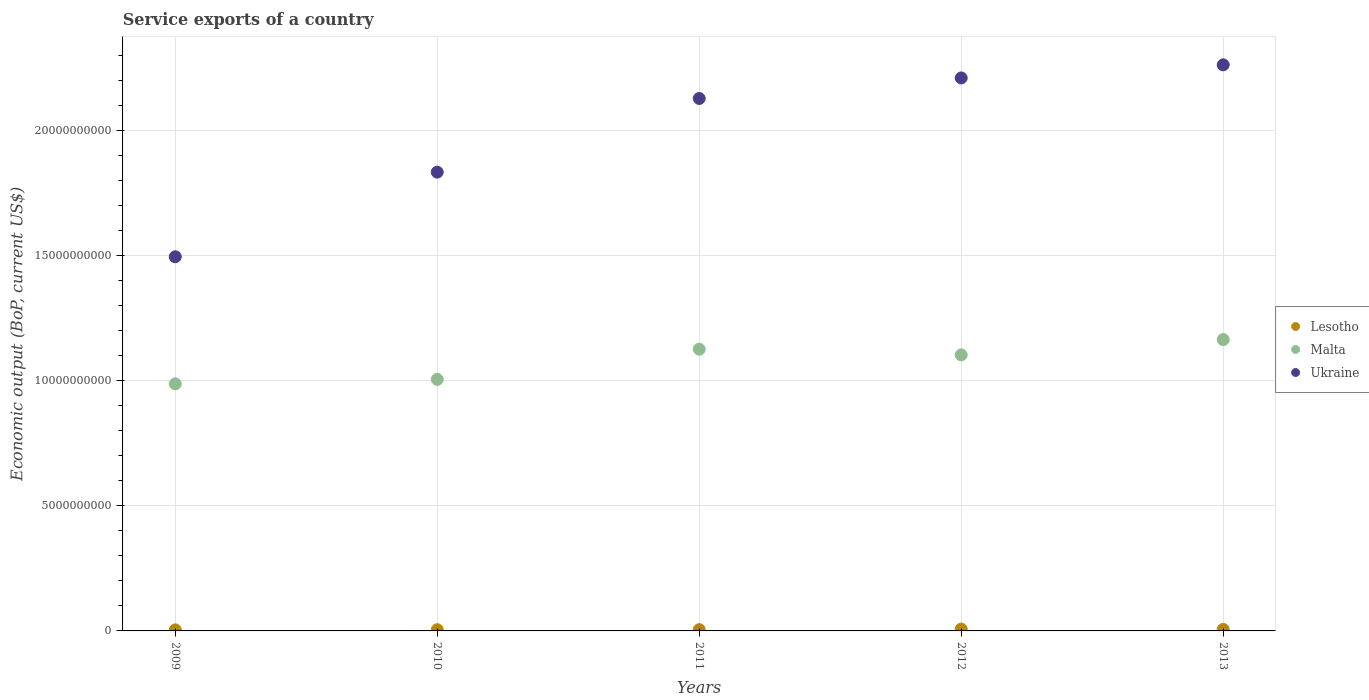How many different coloured dotlines are there?
Provide a short and direct response. 3. Is the number of dotlines equal to the number of legend labels?
Keep it short and to the point. Yes. What is the service exports in Ukraine in 2011?
Provide a short and direct response. 2.13e+1. Across all years, what is the maximum service exports in Malta?
Make the answer very short. 1.16e+1. Across all years, what is the minimum service exports in Malta?
Provide a short and direct response. 9.87e+09. What is the total service exports in Ukraine in the graph?
Your answer should be compact. 9.92e+1. What is the difference between the service exports in Lesotho in 2011 and that in 2012?
Offer a terse response. -2.21e+07. What is the difference between the service exports in Malta in 2013 and the service exports in Ukraine in 2012?
Ensure brevity in your answer.  -1.05e+1. What is the average service exports in Lesotho per year?
Provide a succinct answer. 5.47e+07. In the year 2009, what is the difference between the service exports in Ukraine and service exports in Malta?
Keep it short and to the point. 5.08e+09. In how many years, is the service exports in Lesotho greater than 3000000000 US$?
Keep it short and to the point. 0. What is the ratio of the service exports in Malta in 2009 to that in 2012?
Give a very brief answer. 0.89. What is the difference between the highest and the second highest service exports in Ukraine?
Offer a very short reply. 5.24e+08. What is the difference between the highest and the lowest service exports in Ukraine?
Make the answer very short. 7.67e+09. Does the service exports in Malta monotonically increase over the years?
Provide a short and direct response. No. Is the service exports in Malta strictly greater than the service exports in Lesotho over the years?
Provide a short and direct response. Yes. Is the service exports in Ukraine strictly less than the service exports in Malta over the years?
Your answer should be compact. No. What is the difference between two consecutive major ticks on the Y-axis?
Ensure brevity in your answer.  5.00e+09. Does the graph contain grids?
Your answer should be very brief. Yes. How many legend labels are there?
Your response must be concise. 3. How are the legend labels stacked?
Keep it short and to the point. Vertical. What is the title of the graph?
Give a very brief answer. Service exports of a country. Does "Central African Republic" appear as one of the legend labels in the graph?
Make the answer very short. No. What is the label or title of the X-axis?
Provide a short and direct response. Years. What is the label or title of the Y-axis?
Offer a very short reply. Economic output (BoP, current US$). What is the Economic output (BoP, current US$) in Lesotho in 2009?
Your answer should be compact. 4.15e+07. What is the Economic output (BoP, current US$) in Malta in 2009?
Ensure brevity in your answer.  9.87e+09. What is the Economic output (BoP, current US$) in Ukraine in 2009?
Offer a very short reply. 1.49e+1. What is the Economic output (BoP, current US$) of Lesotho in 2010?
Provide a succinct answer. 4.77e+07. What is the Economic output (BoP, current US$) in Malta in 2010?
Give a very brief answer. 1.00e+1. What is the Economic output (BoP, current US$) of Ukraine in 2010?
Your answer should be compact. 1.83e+1. What is the Economic output (BoP, current US$) of Lesotho in 2011?
Your answer should be compact. 5.08e+07. What is the Economic output (BoP, current US$) of Malta in 2011?
Keep it short and to the point. 1.13e+1. What is the Economic output (BoP, current US$) of Ukraine in 2011?
Offer a very short reply. 2.13e+1. What is the Economic output (BoP, current US$) of Lesotho in 2012?
Offer a terse response. 7.29e+07. What is the Economic output (BoP, current US$) of Malta in 2012?
Your answer should be compact. 1.10e+1. What is the Economic output (BoP, current US$) of Ukraine in 2012?
Ensure brevity in your answer.  2.21e+1. What is the Economic output (BoP, current US$) in Lesotho in 2013?
Ensure brevity in your answer.  6.03e+07. What is the Economic output (BoP, current US$) of Malta in 2013?
Your answer should be very brief. 1.16e+1. What is the Economic output (BoP, current US$) in Ukraine in 2013?
Your answer should be very brief. 2.26e+1. Across all years, what is the maximum Economic output (BoP, current US$) of Lesotho?
Keep it short and to the point. 7.29e+07. Across all years, what is the maximum Economic output (BoP, current US$) of Malta?
Keep it short and to the point. 1.16e+1. Across all years, what is the maximum Economic output (BoP, current US$) in Ukraine?
Make the answer very short. 2.26e+1. Across all years, what is the minimum Economic output (BoP, current US$) in Lesotho?
Offer a terse response. 4.15e+07. Across all years, what is the minimum Economic output (BoP, current US$) in Malta?
Your response must be concise. 9.87e+09. Across all years, what is the minimum Economic output (BoP, current US$) in Ukraine?
Make the answer very short. 1.49e+1. What is the total Economic output (BoP, current US$) of Lesotho in the graph?
Ensure brevity in your answer.  2.73e+08. What is the total Economic output (BoP, current US$) of Malta in the graph?
Your response must be concise. 5.38e+1. What is the total Economic output (BoP, current US$) of Ukraine in the graph?
Provide a short and direct response. 9.92e+1. What is the difference between the Economic output (BoP, current US$) in Lesotho in 2009 and that in 2010?
Offer a terse response. -6.19e+06. What is the difference between the Economic output (BoP, current US$) of Malta in 2009 and that in 2010?
Provide a succinct answer. -1.80e+08. What is the difference between the Economic output (BoP, current US$) of Ukraine in 2009 and that in 2010?
Offer a very short reply. -3.38e+09. What is the difference between the Economic output (BoP, current US$) of Lesotho in 2009 and that in 2011?
Your answer should be very brief. -9.29e+06. What is the difference between the Economic output (BoP, current US$) of Malta in 2009 and that in 2011?
Give a very brief answer. -1.39e+09. What is the difference between the Economic output (BoP, current US$) of Ukraine in 2009 and that in 2011?
Provide a succinct answer. -6.32e+09. What is the difference between the Economic output (BoP, current US$) of Lesotho in 2009 and that in 2012?
Your response must be concise. -3.14e+07. What is the difference between the Economic output (BoP, current US$) of Malta in 2009 and that in 2012?
Your answer should be compact. -1.16e+09. What is the difference between the Economic output (BoP, current US$) of Ukraine in 2009 and that in 2012?
Offer a terse response. -7.14e+09. What is the difference between the Economic output (BoP, current US$) of Lesotho in 2009 and that in 2013?
Keep it short and to the point. -1.88e+07. What is the difference between the Economic output (BoP, current US$) of Malta in 2009 and that in 2013?
Provide a short and direct response. -1.77e+09. What is the difference between the Economic output (BoP, current US$) in Ukraine in 2009 and that in 2013?
Offer a very short reply. -7.67e+09. What is the difference between the Economic output (BoP, current US$) in Lesotho in 2010 and that in 2011?
Ensure brevity in your answer.  -3.10e+06. What is the difference between the Economic output (BoP, current US$) of Malta in 2010 and that in 2011?
Provide a succinct answer. -1.21e+09. What is the difference between the Economic output (BoP, current US$) of Ukraine in 2010 and that in 2011?
Your answer should be compact. -2.94e+09. What is the difference between the Economic output (BoP, current US$) in Lesotho in 2010 and that in 2012?
Offer a very short reply. -2.52e+07. What is the difference between the Economic output (BoP, current US$) of Malta in 2010 and that in 2012?
Provide a succinct answer. -9.79e+08. What is the difference between the Economic output (BoP, current US$) of Ukraine in 2010 and that in 2012?
Ensure brevity in your answer.  -3.76e+09. What is the difference between the Economic output (BoP, current US$) of Lesotho in 2010 and that in 2013?
Keep it short and to the point. -1.26e+07. What is the difference between the Economic output (BoP, current US$) of Malta in 2010 and that in 2013?
Keep it short and to the point. -1.59e+09. What is the difference between the Economic output (BoP, current US$) of Ukraine in 2010 and that in 2013?
Ensure brevity in your answer.  -4.29e+09. What is the difference between the Economic output (BoP, current US$) of Lesotho in 2011 and that in 2012?
Your answer should be compact. -2.21e+07. What is the difference between the Economic output (BoP, current US$) in Malta in 2011 and that in 2012?
Your answer should be compact. 2.27e+08. What is the difference between the Economic output (BoP, current US$) in Ukraine in 2011 and that in 2012?
Give a very brief answer. -8.20e+08. What is the difference between the Economic output (BoP, current US$) of Lesotho in 2011 and that in 2013?
Offer a very short reply. -9.50e+06. What is the difference between the Economic output (BoP, current US$) in Malta in 2011 and that in 2013?
Offer a terse response. -3.83e+08. What is the difference between the Economic output (BoP, current US$) of Ukraine in 2011 and that in 2013?
Ensure brevity in your answer.  -1.34e+09. What is the difference between the Economic output (BoP, current US$) in Lesotho in 2012 and that in 2013?
Make the answer very short. 1.26e+07. What is the difference between the Economic output (BoP, current US$) in Malta in 2012 and that in 2013?
Keep it short and to the point. -6.10e+08. What is the difference between the Economic output (BoP, current US$) of Ukraine in 2012 and that in 2013?
Give a very brief answer. -5.24e+08. What is the difference between the Economic output (BoP, current US$) of Lesotho in 2009 and the Economic output (BoP, current US$) of Malta in 2010?
Give a very brief answer. -1.00e+1. What is the difference between the Economic output (BoP, current US$) of Lesotho in 2009 and the Economic output (BoP, current US$) of Ukraine in 2010?
Ensure brevity in your answer.  -1.83e+1. What is the difference between the Economic output (BoP, current US$) in Malta in 2009 and the Economic output (BoP, current US$) in Ukraine in 2010?
Provide a succinct answer. -8.46e+09. What is the difference between the Economic output (BoP, current US$) of Lesotho in 2009 and the Economic output (BoP, current US$) of Malta in 2011?
Your response must be concise. -1.12e+1. What is the difference between the Economic output (BoP, current US$) in Lesotho in 2009 and the Economic output (BoP, current US$) in Ukraine in 2011?
Provide a succinct answer. -2.12e+1. What is the difference between the Economic output (BoP, current US$) in Malta in 2009 and the Economic output (BoP, current US$) in Ukraine in 2011?
Provide a succinct answer. -1.14e+1. What is the difference between the Economic output (BoP, current US$) in Lesotho in 2009 and the Economic output (BoP, current US$) in Malta in 2012?
Your answer should be very brief. -1.10e+1. What is the difference between the Economic output (BoP, current US$) of Lesotho in 2009 and the Economic output (BoP, current US$) of Ukraine in 2012?
Offer a very short reply. -2.20e+1. What is the difference between the Economic output (BoP, current US$) of Malta in 2009 and the Economic output (BoP, current US$) of Ukraine in 2012?
Ensure brevity in your answer.  -1.22e+1. What is the difference between the Economic output (BoP, current US$) in Lesotho in 2009 and the Economic output (BoP, current US$) in Malta in 2013?
Provide a succinct answer. -1.16e+1. What is the difference between the Economic output (BoP, current US$) of Lesotho in 2009 and the Economic output (BoP, current US$) of Ukraine in 2013?
Give a very brief answer. -2.26e+1. What is the difference between the Economic output (BoP, current US$) of Malta in 2009 and the Economic output (BoP, current US$) of Ukraine in 2013?
Your answer should be very brief. -1.27e+1. What is the difference between the Economic output (BoP, current US$) in Lesotho in 2010 and the Economic output (BoP, current US$) in Malta in 2011?
Give a very brief answer. -1.12e+1. What is the difference between the Economic output (BoP, current US$) in Lesotho in 2010 and the Economic output (BoP, current US$) in Ukraine in 2011?
Keep it short and to the point. -2.12e+1. What is the difference between the Economic output (BoP, current US$) in Malta in 2010 and the Economic output (BoP, current US$) in Ukraine in 2011?
Provide a short and direct response. -1.12e+1. What is the difference between the Economic output (BoP, current US$) of Lesotho in 2010 and the Economic output (BoP, current US$) of Malta in 2012?
Provide a short and direct response. -1.10e+1. What is the difference between the Economic output (BoP, current US$) of Lesotho in 2010 and the Economic output (BoP, current US$) of Ukraine in 2012?
Provide a succinct answer. -2.20e+1. What is the difference between the Economic output (BoP, current US$) of Malta in 2010 and the Economic output (BoP, current US$) of Ukraine in 2012?
Offer a very short reply. -1.20e+1. What is the difference between the Economic output (BoP, current US$) of Lesotho in 2010 and the Economic output (BoP, current US$) of Malta in 2013?
Make the answer very short. -1.16e+1. What is the difference between the Economic output (BoP, current US$) of Lesotho in 2010 and the Economic output (BoP, current US$) of Ukraine in 2013?
Make the answer very short. -2.26e+1. What is the difference between the Economic output (BoP, current US$) in Malta in 2010 and the Economic output (BoP, current US$) in Ukraine in 2013?
Your answer should be compact. -1.26e+1. What is the difference between the Economic output (BoP, current US$) in Lesotho in 2011 and the Economic output (BoP, current US$) in Malta in 2012?
Ensure brevity in your answer.  -1.10e+1. What is the difference between the Economic output (BoP, current US$) of Lesotho in 2011 and the Economic output (BoP, current US$) of Ukraine in 2012?
Your answer should be very brief. -2.20e+1. What is the difference between the Economic output (BoP, current US$) in Malta in 2011 and the Economic output (BoP, current US$) in Ukraine in 2012?
Give a very brief answer. -1.08e+1. What is the difference between the Economic output (BoP, current US$) in Lesotho in 2011 and the Economic output (BoP, current US$) in Malta in 2013?
Ensure brevity in your answer.  -1.16e+1. What is the difference between the Economic output (BoP, current US$) in Lesotho in 2011 and the Economic output (BoP, current US$) in Ukraine in 2013?
Give a very brief answer. -2.26e+1. What is the difference between the Economic output (BoP, current US$) in Malta in 2011 and the Economic output (BoP, current US$) in Ukraine in 2013?
Offer a terse response. -1.14e+1. What is the difference between the Economic output (BoP, current US$) of Lesotho in 2012 and the Economic output (BoP, current US$) of Malta in 2013?
Your answer should be very brief. -1.16e+1. What is the difference between the Economic output (BoP, current US$) in Lesotho in 2012 and the Economic output (BoP, current US$) in Ukraine in 2013?
Provide a short and direct response. -2.25e+1. What is the difference between the Economic output (BoP, current US$) in Malta in 2012 and the Economic output (BoP, current US$) in Ukraine in 2013?
Keep it short and to the point. -1.16e+1. What is the average Economic output (BoP, current US$) in Lesotho per year?
Provide a short and direct response. 5.47e+07. What is the average Economic output (BoP, current US$) in Malta per year?
Provide a short and direct response. 1.08e+1. What is the average Economic output (BoP, current US$) in Ukraine per year?
Your answer should be very brief. 1.98e+1. In the year 2009, what is the difference between the Economic output (BoP, current US$) in Lesotho and Economic output (BoP, current US$) in Malta?
Your response must be concise. -9.83e+09. In the year 2009, what is the difference between the Economic output (BoP, current US$) of Lesotho and Economic output (BoP, current US$) of Ukraine?
Provide a short and direct response. -1.49e+1. In the year 2009, what is the difference between the Economic output (BoP, current US$) of Malta and Economic output (BoP, current US$) of Ukraine?
Provide a short and direct response. -5.08e+09. In the year 2010, what is the difference between the Economic output (BoP, current US$) in Lesotho and Economic output (BoP, current US$) in Malta?
Keep it short and to the point. -1.00e+1. In the year 2010, what is the difference between the Economic output (BoP, current US$) of Lesotho and Economic output (BoP, current US$) of Ukraine?
Provide a succinct answer. -1.83e+1. In the year 2010, what is the difference between the Economic output (BoP, current US$) in Malta and Economic output (BoP, current US$) in Ukraine?
Your response must be concise. -8.28e+09. In the year 2011, what is the difference between the Economic output (BoP, current US$) of Lesotho and Economic output (BoP, current US$) of Malta?
Make the answer very short. -1.12e+1. In the year 2011, what is the difference between the Economic output (BoP, current US$) in Lesotho and Economic output (BoP, current US$) in Ukraine?
Provide a succinct answer. -2.12e+1. In the year 2011, what is the difference between the Economic output (BoP, current US$) in Malta and Economic output (BoP, current US$) in Ukraine?
Offer a terse response. -1.00e+1. In the year 2012, what is the difference between the Economic output (BoP, current US$) of Lesotho and Economic output (BoP, current US$) of Malta?
Offer a very short reply. -1.10e+1. In the year 2012, what is the difference between the Economic output (BoP, current US$) of Lesotho and Economic output (BoP, current US$) of Ukraine?
Ensure brevity in your answer.  -2.20e+1. In the year 2012, what is the difference between the Economic output (BoP, current US$) of Malta and Economic output (BoP, current US$) of Ukraine?
Offer a terse response. -1.11e+1. In the year 2013, what is the difference between the Economic output (BoP, current US$) of Lesotho and Economic output (BoP, current US$) of Malta?
Offer a terse response. -1.16e+1. In the year 2013, what is the difference between the Economic output (BoP, current US$) of Lesotho and Economic output (BoP, current US$) of Ukraine?
Offer a very short reply. -2.26e+1. In the year 2013, what is the difference between the Economic output (BoP, current US$) in Malta and Economic output (BoP, current US$) in Ukraine?
Keep it short and to the point. -1.10e+1. What is the ratio of the Economic output (BoP, current US$) of Lesotho in 2009 to that in 2010?
Make the answer very short. 0.87. What is the ratio of the Economic output (BoP, current US$) in Malta in 2009 to that in 2010?
Your answer should be compact. 0.98. What is the ratio of the Economic output (BoP, current US$) in Ukraine in 2009 to that in 2010?
Offer a terse response. 0.82. What is the ratio of the Economic output (BoP, current US$) of Lesotho in 2009 to that in 2011?
Offer a very short reply. 0.82. What is the ratio of the Economic output (BoP, current US$) in Malta in 2009 to that in 2011?
Provide a succinct answer. 0.88. What is the ratio of the Economic output (BoP, current US$) in Ukraine in 2009 to that in 2011?
Your answer should be very brief. 0.7. What is the ratio of the Economic output (BoP, current US$) of Lesotho in 2009 to that in 2012?
Keep it short and to the point. 0.57. What is the ratio of the Economic output (BoP, current US$) of Malta in 2009 to that in 2012?
Your answer should be very brief. 0.89. What is the ratio of the Economic output (BoP, current US$) in Ukraine in 2009 to that in 2012?
Provide a succinct answer. 0.68. What is the ratio of the Economic output (BoP, current US$) in Lesotho in 2009 to that in 2013?
Your answer should be compact. 0.69. What is the ratio of the Economic output (BoP, current US$) in Malta in 2009 to that in 2013?
Offer a terse response. 0.85. What is the ratio of the Economic output (BoP, current US$) of Ukraine in 2009 to that in 2013?
Your answer should be compact. 0.66. What is the ratio of the Economic output (BoP, current US$) of Lesotho in 2010 to that in 2011?
Offer a terse response. 0.94. What is the ratio of the Economic output (BoP, current US$) in Malta in 2010 to that in 2011?
Ensure brevity in your answer.  0.89. What is the ratio of the Economic output (BoP, current US$) of Ukraine in 2010 to that in 2011?
Ensure brevity in your answer.  0.86. What is the ratio of the Economic output (BoP, current US$) in Lesotho in 2010 to that in 2012?
Offer a very short reply. 0.65. What is the ratio of the Economic output (BoP, current US$) of Malta in 2010 to that in 2012?
Your answer should be compact. 0.91. What is the ratio of the Economic output (BoP, current US$) in Ukraine in 2010 to that in 2012?
Offer a very short reply. 0.83. What is the ratio of the Economic output (BoP, current US$) in Lesotho in 2010 to that in 2013?
Your answer should be very brief. 0.79. What is the ratio of the Economic output (BoP, current US$) of Malta in 2010 to that in 2013?
Provide a short and direct response. 0.86. What is the ratio of the Economic output (BoP, current US$) in Ukraine in 2010 to that in 2013?
Give a very brief answer. 0.81. What is the ratio of the Economic output (BoP, current US$) in Lesotho in 2011 to that in 2012?
Your answer should be compact. 0.7. What is the ratio of the Economic output (BoP, current US$) in Malta in 2011 to that in 2012?
Offer a very short reply. 1.02. What is the ratio of the Economic output (BoP, current US$) of Ukraine in 2011 to that in 2012?
Keep it short and to the point. 0.96. What is the ratio of the Economic output (BoP, current US$) of Lesotho in 2011 to that in 2013?
Provide a succinct answer. 0.84. What is the ratio of the Economic output (BoP, current US$) in Malta in 2011 to that in 2013?
Your answer should be very brief. 0.97. What is the ratio of the Economic output (BoP, current US$) in Ukraine in 2011 to that in 2013?
Offer a very short reply. 0.94. What is the ratio of the Economic output (BoP, current US$) of Lesotho in 2012 to that in 2013?
Your answer should be compact. 1.21. What is the ratio of the Economic output (BoP, current US$) of Malta in 2012 to that in 2013?
Offer a very short reply. 0.95. What is the ratio of the Economic output (BoP, current US$) in Ukraine in 2012 to that in 2013?
Offer a very short reply. 0.98. What is the difference between the highest and the second highest Economic output (BoP, current US$) in Lesotho?
Provide a succinct answer. 1.26e+07. What is the difference between the highest and the second highest Economic output (BoP, current US$) of Malta?
Keep it short and to the point. 3.83e+08. What is the difference between the highest and the second highest Economic output (BoP, current US$) in Ukraine?
Your answer should be very brief. 5.24e+08. What is the difference between the highest and the lowest Economic output (BoP, current US$) of Lesotho?
Ensure brevity in your answer.  3.14e+07. What is the difference between the highest and the lowest Economic output (BoP, current US$) in Malta?
Provide a succinct answer. 1.77e+09. What is the difference between the highest and the lowest Economic output (BoP, current US$) of Ukraine?
Offer a terse response. 7.67e+09. 